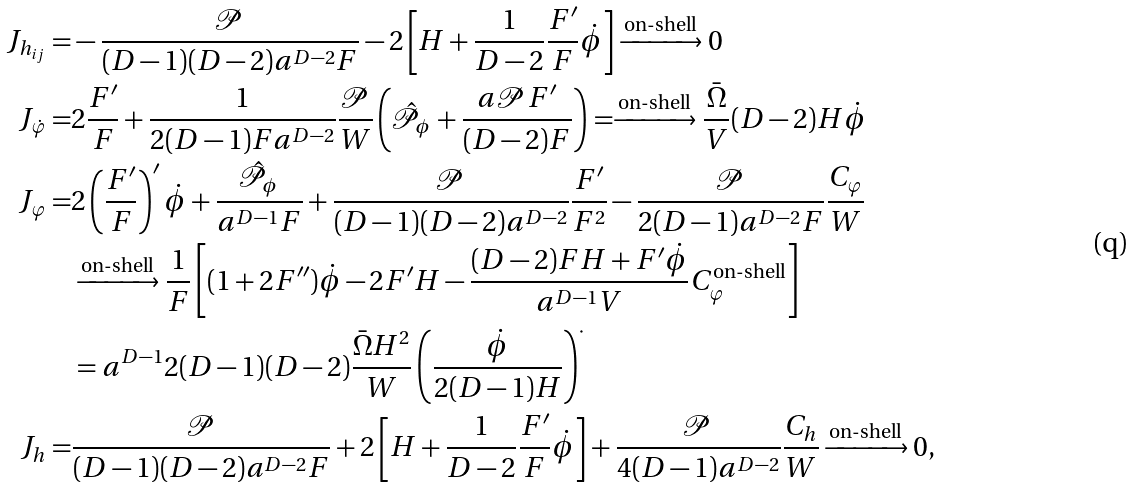Convert formula to latex. <formula><loc_0><loc_0><loc_500><loc_500>J _ { h _ { i j } } = & - \frac { \mathcal { P } } { ( D - 1 ) ( D - 2 ) a ^ { D - 2 } F } - 2 \left [ H + \frac { 1 } { D - 2 } \frac { F ^ { \prime } } { F } \dot { \phi } \right ] \xrightarrow { \text {on-shell} } 0 \\ J _ { \dot { \varphi } } = & 2 \frac { F ^ { \prime } } { F } + \frac { 1 } { 2 ( D - 1 ) F a ^ { D - 2 } } \frac { \mathcal { P } } { W } \left ( \hat { \mathcal { P } } _ { \phi } + \frac { a \mathcal { P } F ^ { \prime } } { ( D - 2 ) F } \right ) = \xrightarrow { \text {on-shell} } \frac { \bar { \Omega } } { V } ( D - 2 ) H \dot { \phi } \\ J _ { \varphi } = & 2 \left ( \frac { F ^ { \prime } } { F } \right ) ^ { \prime } \dot { \phi } + \frac { \hat { \mathcal { P } } _ { \phi } } { a ^ { D - 1 } F } + \frac { \mathcal { P } } { ( D - 1 ) ( D - 2 ) a ^ { D - 2 } } \frac { F ^ { \prime } } { F ^ { 2 } } - \frac { \mathcal { P } } { 2 ( D - 1 ) a ^ { D - 2 } F } \frac { C _ { \varphi } } { W } \\ & \xrightarrow { \text {on-shell} } \frac { 1 } { F } \left [ ( 1 + 2 F ^ { \prime \prime } ) \dot { \phi } - 2 F ^ { \prime } H - \frac { ( D - 2 ) F H + F ^ { \prime } \dot { \phi } } { a ^ { D - 1 } V } C ^ { \text {on-shell} } _ { \varphi } \right ] \\ & = a ^ { D - 1 } 2 ( D - 1 ) ( D - 2 ) \frac { \bar { \Omega } H ^ { 2 } } { W } \left ( \frac { \dot { \phi } } { 2 ( D - 1 ) H } \right ) ^ { \cdot } \\ J _ { h } = & \frac { \mathcal { P } } { ( D - 1 ) ( D - 2 ) a ^ { D - 2 } F } + 2 \left [ H + \frac { 1 } { D - 2 } \frac { F ^ { \prime } } { F } \dot { \phi } \right ] + \frac { \mathcal { P } } { 4 ( D - 1 ) a ^ { D - 2 } } \frac { C _ { h } } { W } \xrightarrow { \text {on-shell} } 0 ,</formula> 